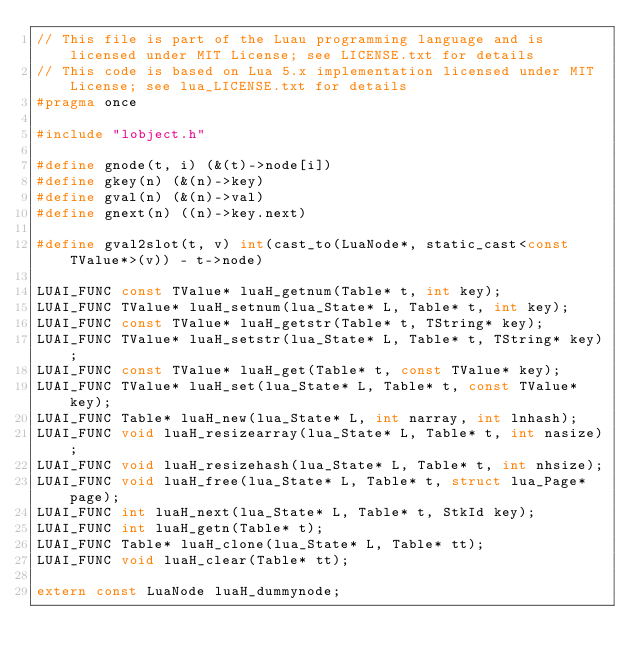Convert code to text. <code><loc_0><loc_0><loc_500><loc_500><_C_>// This file is part of the Luau programming language and is licensed under MIT License; see LICENSE.txt for details
// This code is based on Lua 5.x implementation licensed under MIT License; see lua_LICENSE.txt for details
#pragma once

#include "lobject.h"

#define gnode(t, i) (&(t)->node[i])
#define gkey(n) (&(n)->key)
#define gval(n) (&(n)->val)
#define gnext(n) ((n)->key.next)

#define gval2slot(t, v) int(cast_to(LuaNode*, static_cast<const TValue*>(v)) - t->node)

LUAI_FUNC const TValue* luaH_getnum(Table* t, int key);
LUAI_FUNC TValue* luaH_setnum(lua_State* L, Table* t, int key);
LUAI_FUNC const TValue* luaH_getstr(Table* t, TString* key);
LUAI_FUNC TValue* luaH_setstr(lua_State* L, Table* t, TString* key);
LUAI_FUNC const TValue* luaH_get(Table* t, const TValue* key);
LUAI_FUNC TValue* luaH_set(lua_State* L, Table* t, const TValue* key);
LUAI_FUNC Table* luaH_new(lua_State* L, int narray, int lnhash);
LUAI_FUNC void luaH_resizearray(lua_State* L, Table* t, int nasize);
LUAI_FUNC void luaH_resizehash(lua_State* L, Table* t, int nhsize);
LUAI_FUNC void luaH_free(lua_State* L, Table* t, struct lua_Page* page);
LUAI_FUNC int luaH_next(lua_State* L, Table* t, StkId key);
LUAI_FUNC int luaH_getn(Table* t);
LUAI_FUNC Table* luaH_clone(lua_State* L, Table* tt);
LUAI_FUNC void luaH_clear(Table* tt);

extern const LuaNode luaH_dummynode;
</code> 